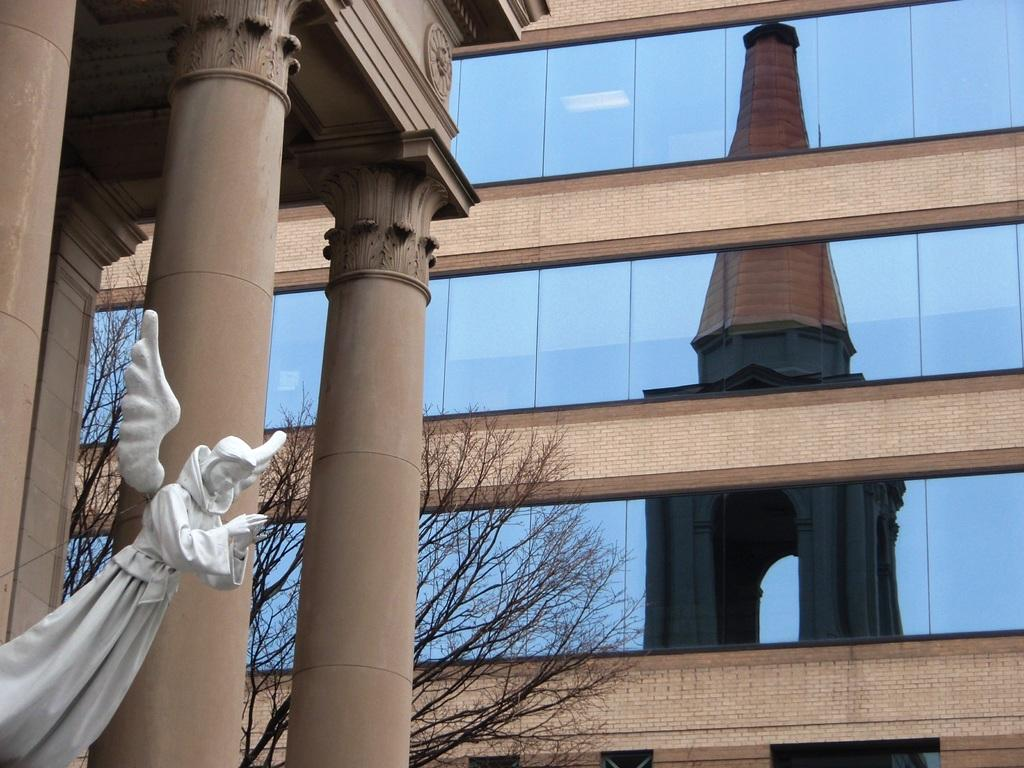What type of structures can be seen in the image? There are two brown pillars and a glass building with brown bricks in the image. What type of artwork is present in the image? There is a marble statue in the image. What is the condition of the trees visible in the image? The trees visible in the image are dry. What can be seen in the background of the image? There is a glass building with brown bricks in the background of the image. What type of stitch is used to create the boundary of the town in the image? There is no town or stitching present in the image; it features two brown pillars, a marble statue, a glass building, and dry trees. 